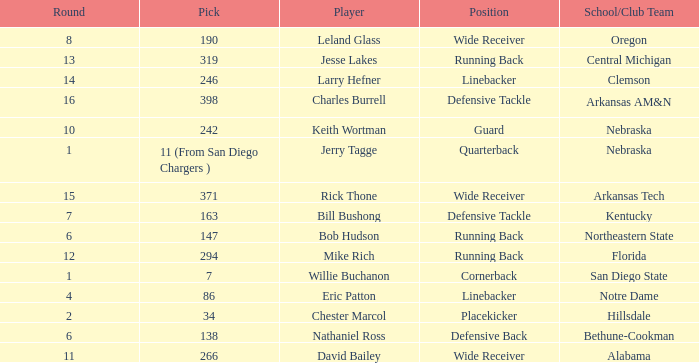Which round has a position that is cornerback? 1.0. 